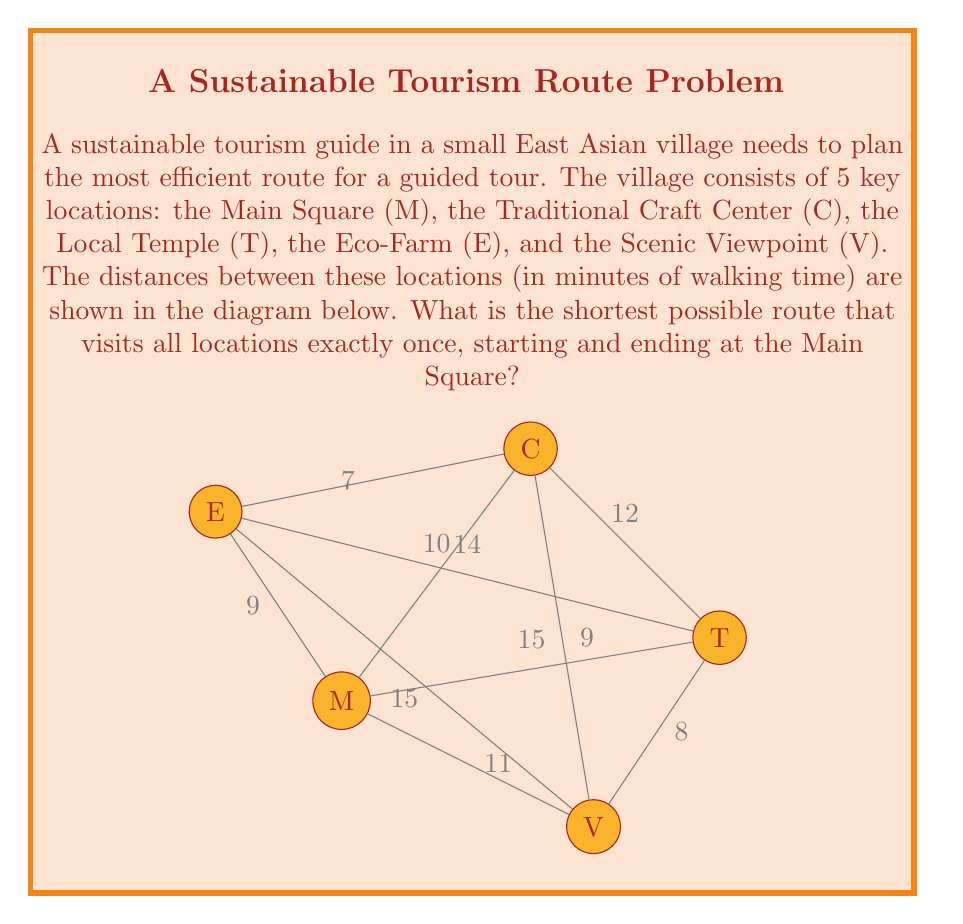Give your solution to this math problem. To solve this problem, we need to use the concept of finding the shortest Hamiltonian cycle, which is also known as the Traveling Salesman Problem. Given the small number of locations, we can solve this by systematically checking all possible routes.

Step 1: List all possible routes.
There are $(5-1)! = 24$ possible routes, as we fix the starting and ending point (M). Some of these routes are:
M-C-T-E-V-M
M-C-T-V-E-M
M-C-E-T-V-M
...and so on.

Step 2: Calculate the total distance for each route.
Let's calculate for a few routes:

M-C-T-E-V-M:
$10 + 12 + 14 + 15 + 11 = 62$ minutes

M-C-T-V-E-M:
$10 + 12 + 8 + 15 + 9 = 54$ minutes

M-C-E-T-V-M:
$10 + 7 + 14 + 8 + 11 = 50$ minutes

Step 3: Compare all routes and find the shortest one.
After calculating all 24 routes, we find that the shortest route is:

M-C-E-V-T-M

Step 4: Calculate the total distance of the shortest route.
M to C: 10 minutes
C to E: 7 minutes
E to V: 15 minutes
V to T: 8 minutes
T to M: 15 minutes

Total: $10 + 7 + 15 + 8 + 15 = 55$ minutes

Therefore, the most efficient route for the guided tour is M-C-E-V-T-M, which takes 55 minutes to complete.
Answer: M-C-E-V-T-M (55 minutes) 